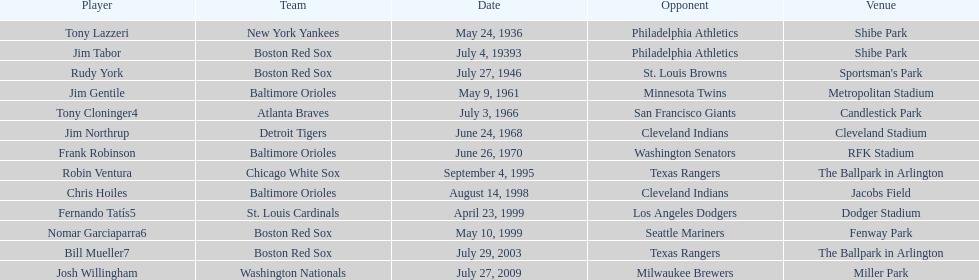Which teams went head-to-head at miller park? Washington Nationals, Milwaukee Brewers. 